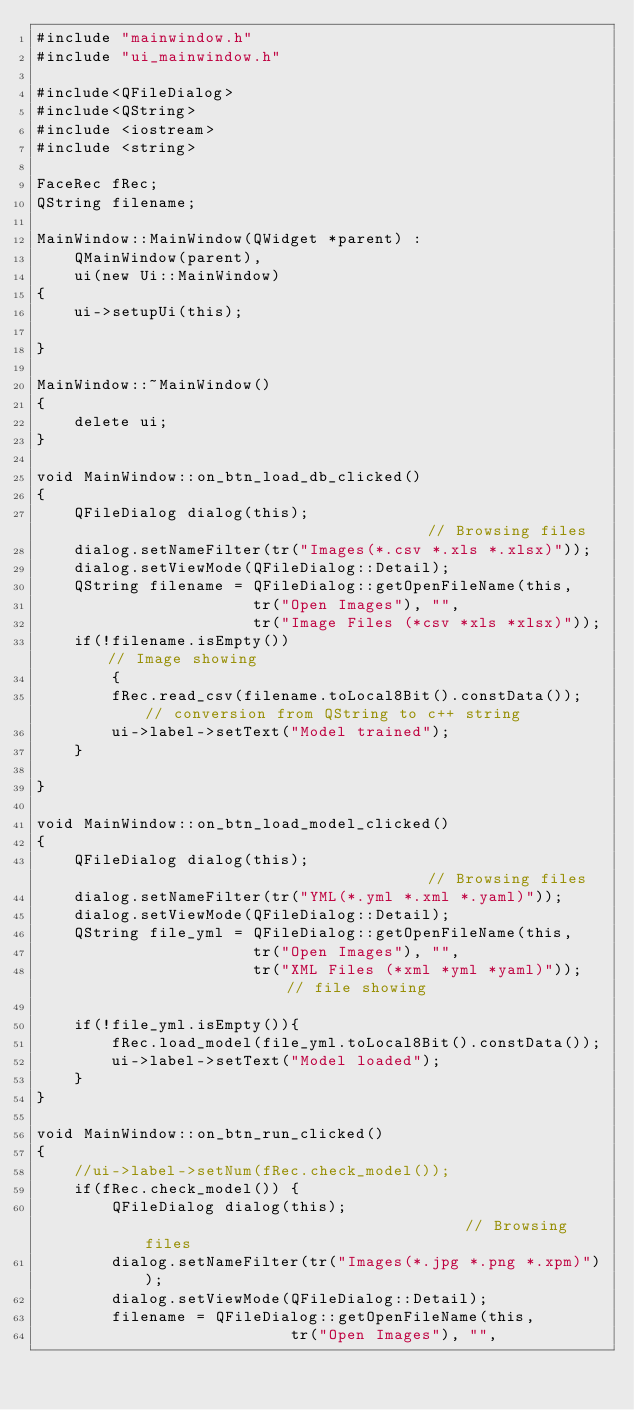<code> <loc_0><loc_0><loc_500><loc_500><_C++_>#include "mainwindow.h"
#include "ui_mainwindow.h"

#include<QFileDialog>
#include<QString>
#include <iostream>
#include <string>

FaceRec fRec;
QString filename;

MainWindow::MainWindow(QWidget *parent) :
    QMainWindow(parent),
    ui(new Ui::MainWindow)
{
    ui->setupUi(this);

}

MainWindow::~MainWindow()
{
    delete ui;
}

void MainWindow::on_btn_load_db_clicked()
{
    QFileDialog dialog(this);                                   // Browsing files
    dialog.setNameFilter(tr("Images(*.csv *.xls *.xlsx)"));
    dialog.setViewMode(QFileDialog::Detail);
    QString filename = QFileDialog::getOpenFileName(this,
                       tr("Open Images"), "",
                       tr("Image Files (*csv *xls *xlsx)"));
    if(!filename.isEmpty())                                 // Image showing
        {
        fRec.read_csv(filename.toLocal8Bit().constData()); // conversion from QString to c++ string
        ui->label->setText("Model trained");
    }

}

void MainWindow::on_btn_load_model_clicked()
{
    QFileDialog dialog(this);                                   // Browsing files
    dialog.setNameFilter(tr("YML(*.yml *.xml *.yaml)"));
    dialog.setViewMode(QFileDialog::Detail);
    QString file_yml = QFileDialog::getOpenFileName(this,
                       tr("Open Images"), "",
                       tr("XML Files (*xml *yml *yaml)")); // file showing

    if(!file_yml.isEmpty()){
        fRec.load_model(file_yml.toLocal8Bit().constData());
        ui->label->setText("Model loaded");
    }
}

void MainWindow::on_btn_run_clicked()
{
    //ui->label->setNum(fRec.check_model());
    if(fRec.check_model()) {
        QFileDialog dialog(this);                                   // Browsing files
        dialog.setNameFilter(tr("Images(*.jpg *.png *.xpm)"));
        dialog.setViewMode(QFileDialog::Detail);
        filename = QFileDialog::getOpenFileName(this,
                           tr("Open Images"), "",</code> 